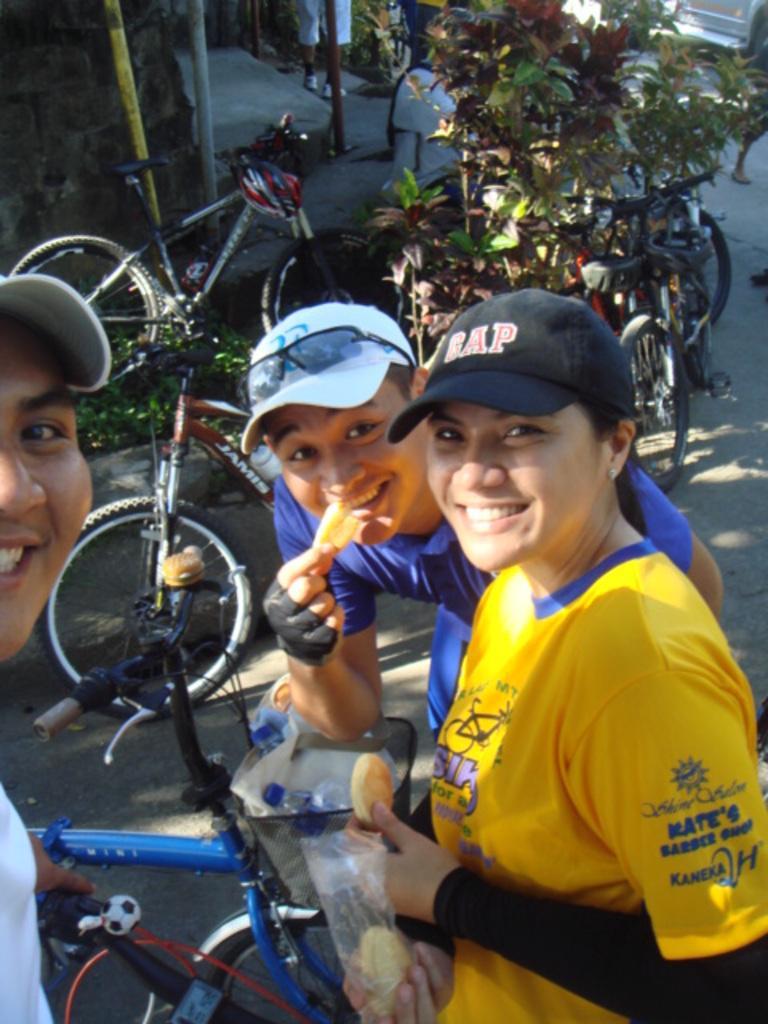Describe this image in one or two sentences. In this image I can see three persons standing. The person in front wearing yellow color dress and the other person wearing blue color dress. Background I can see few bicycles and plants in green color. 